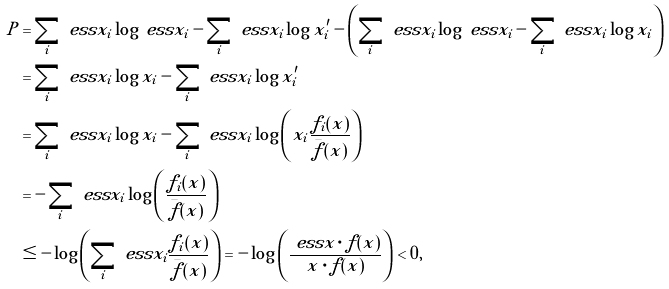Convert formula to latex. <formula><loc_0><loc_0><loc_500><loc_500>P & = \sum _ { i } { \ e s s { x } _ { i } \log { \ e s s { x } _ { i } } } - \sum _ { i } { \ e s s { x } _ { i } \log { x _ { i } ^ { \prime } } } - \left ( \sum _ { i } { \ e s s { x } _ { i } \log { \ e s s { x } _ { i } } } - \sum _ { i } { \ e s s { x } _ { i } \log { x _ { i } } } \right ) \\ & = \sum _ { i } { \ e s s { x } _ { i } \log { x _ { i } } } - \sum _ { i } { \ e s s { x } _ { i } \log { x _ { i } ^ { \prime } } } \\ & = \sum _ { i } { \ e s s { x } _ { i } \log { x _ { i } } } - \sum _ { i } { \ e s s { x } _ { i } \log { \left ( x _ { i } \frac { f _ { i } ( x ) } { \bar { f } ( x ) } \right ) } } \\ & = - \sum _ { i } { \ e s s { x } _ { i } \log { \left ( \frac { f _ { i } ( x ) } { \bar { f } ( x ) } \right ) } } \\ & \leq - \log { \left ( \sum _ { i } { \ e s s { x } _ { i } \frac { f _ { i } ( x ) } { \bar { f } ( x ) } } \right ) } = - \log { \left ( \frac { \ e s s { x } \cdot f ( x ) } { x \cdot f ( x ) } \right ) } < 0 , \\</formula> 